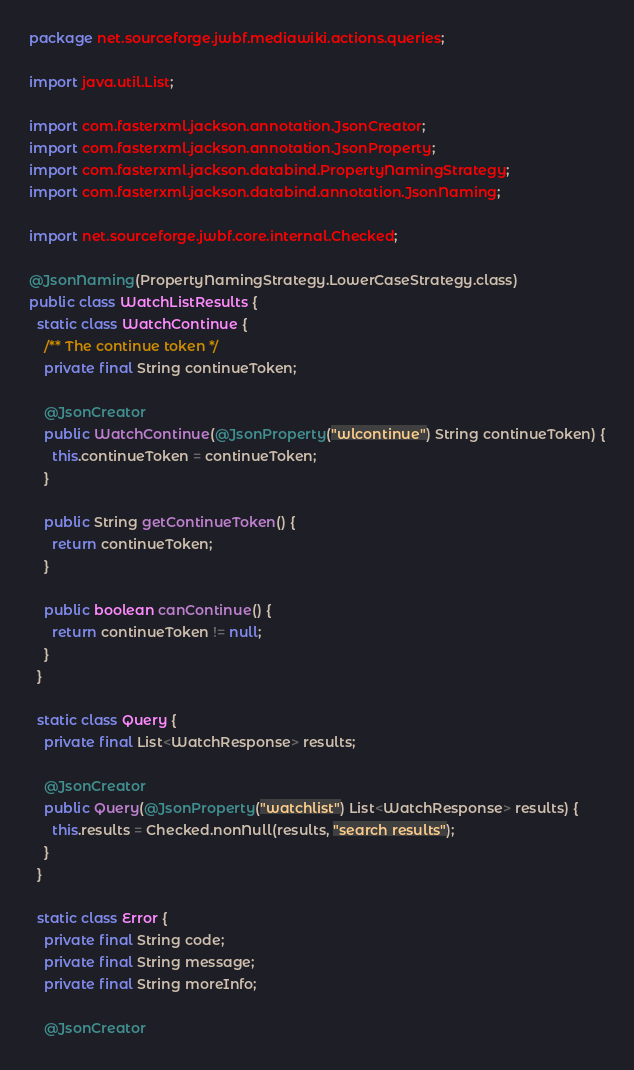<code> <loc_0><loc_0><loc_500><loc_500><_Java_>package net.sourceforge.jwbf.mediawiki.actions.queries;

import java.util.List;

import com.fasterxml.jackson.annotation.JsonCreator;
import com.fasterxml.jackson.annotation.JsonProperty;
import com.fasterxml.jackson.databind.PropertyNamingStrategy;
import com.fasterxml.jackson.databind.annotation.JsonNaming;

import net.sourceforge.jwbf.core.internal.Checked;

@JsonNaming(PropertyNamingStrategy.LowerCaseStrategy.class)
public class WatchListResults {
  static class WatchContinue {
    /** The continue token */
    private final String continueToken;

    @JsonCreator
    public WatchContinue(@JsonProperty("wlcontinue") String continueToken) {
      this.continueToken = continueToken;
    }

    public String getContinueToken() {
      return continueToken;
    }

    public boolean canContinue() {
      return continueToken != null;
    }
  }

  static class Query {
    private final List<WatchResponse> results;

    @JsonCreator
    public Query(@JsonProperty("watchlist") List<WatchResponse> results) {
      this.results = Checked.nonNull(results, "search results");
    }
  }

  static class Error {
    private final String code;
    private final String message;
    private final String moreInfo;

    @JsonCreator</code> 